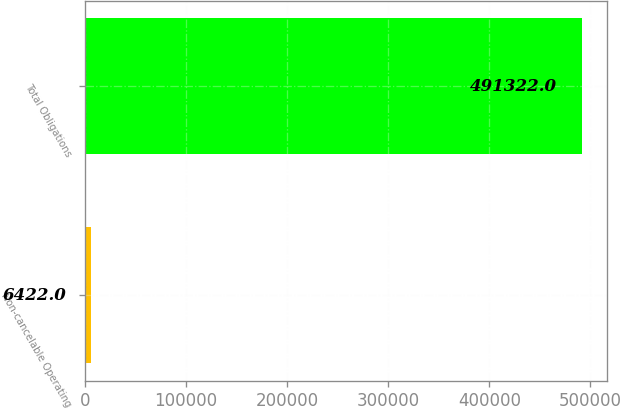Convert chart. <chart><loc_0><loc_0><loc_500><loc_500><bar_chart><fcel>Non-cancelable Operating<fcel>Total Obligations<nl><fcel>6422<fcel>491322<nl></chart> 